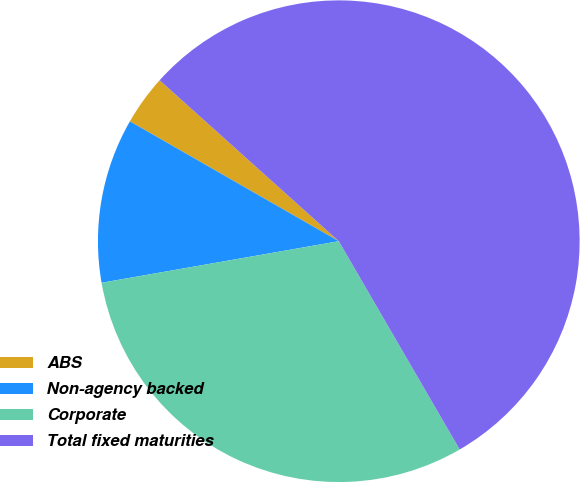Convert chart to OTSL. <chart><loc_0><loc_0><loc_500><loc_500><pie_chart><fcel>ABS<fcel>Non-agency backed<fcel>Corporate<fcel>Total fixed maturities<nl><fcel>3.36%<fcel>11.05%<fcel>30.61%<fcel>54.98%<nl></chart> 